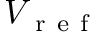<formula> <loc_0><loc_0><loc_500><loc_500>V _ { r e f }</formula> 